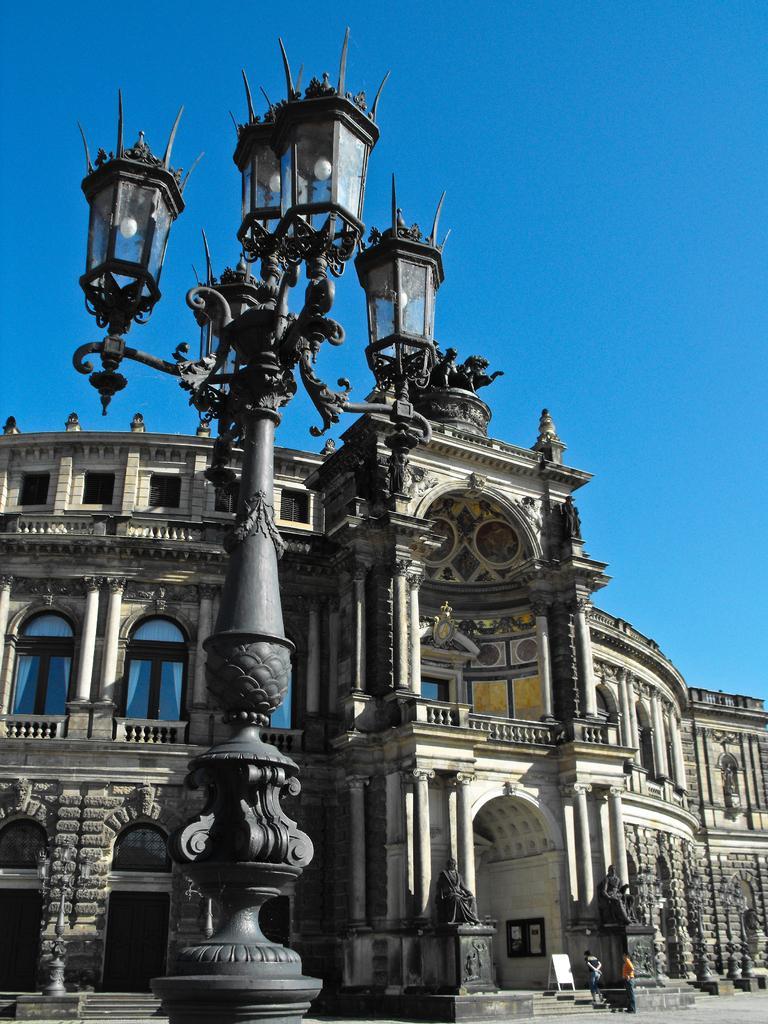In one or two sentences, can you explain what this image depicts? In the center of the image we can see the buildings, windows, wall, pillars, electric light pole, board, stairs, two persons, statues. At the top of the image we can see the sky. At the bottom of the image we can see the ground. 